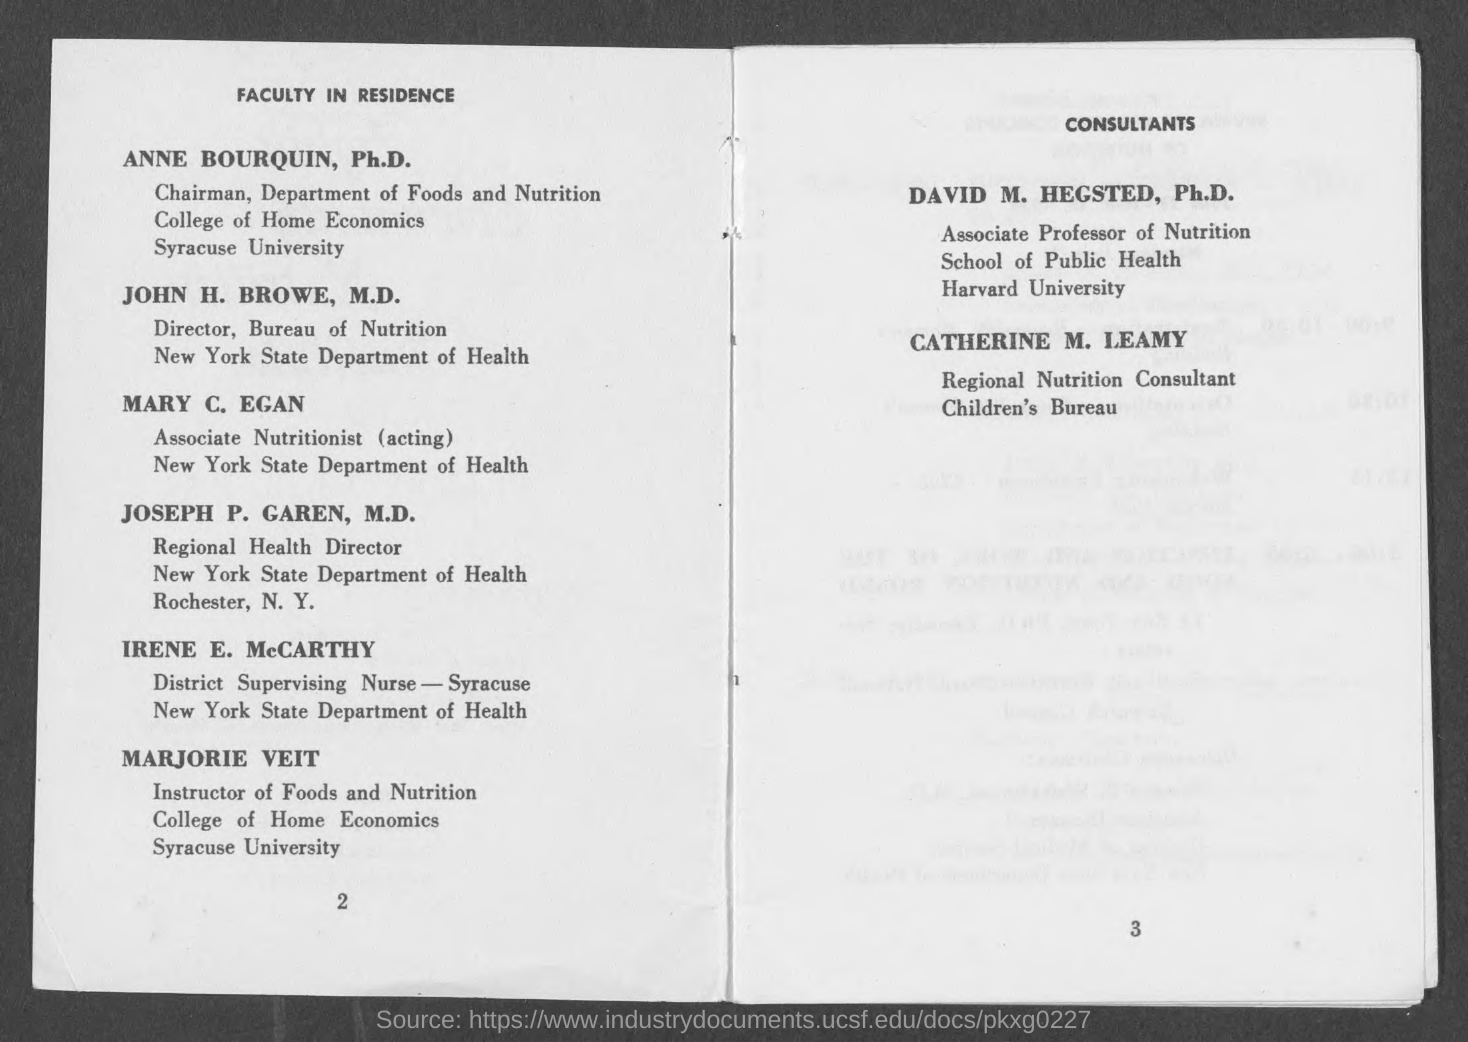Give some essential details in this illustration. John H. Browe, M.D., is the Director of the Bureau of Nutrition. It is my great pleasure to introduce to you, ANNE BOURQUIN, Ph.D., who is the Chairman of the Department of Foods and Nutrition. 